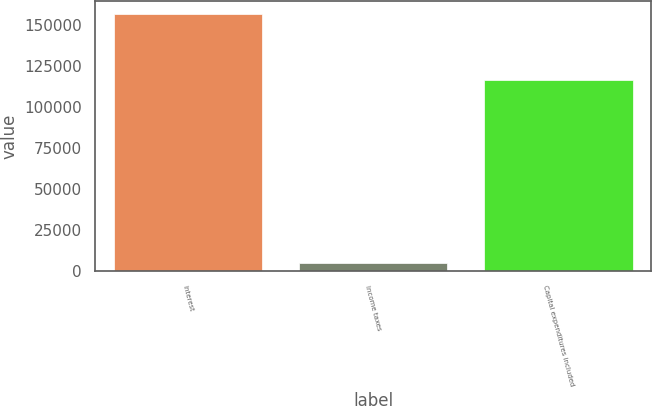Convert chart to OTSL. <chart><loc_0><loc_0><loc_500><loc_500><bar_chart><fcel>Interest<fcel>Income taxes<fcel>Capital expenditures included<nl><fcel>156668<fcel>5264<fcel>116194<nl></chart> 